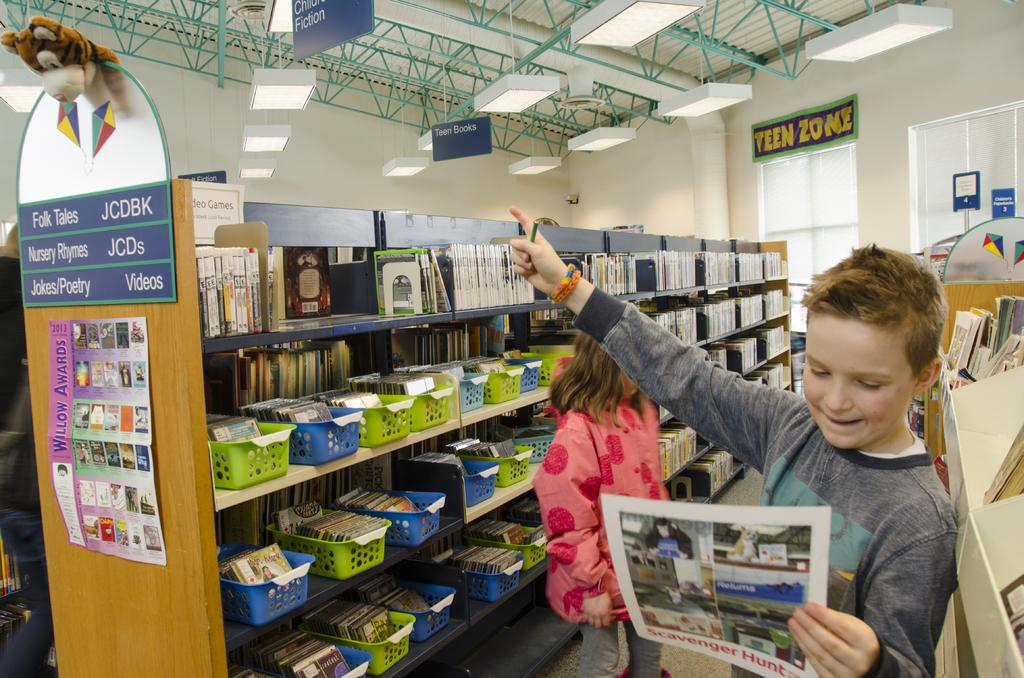<image>
Offer a succinct explanation of the picture presented. Two children are at a section in the library that has fairy tales, nursery rhymes and jokes/poetry. 